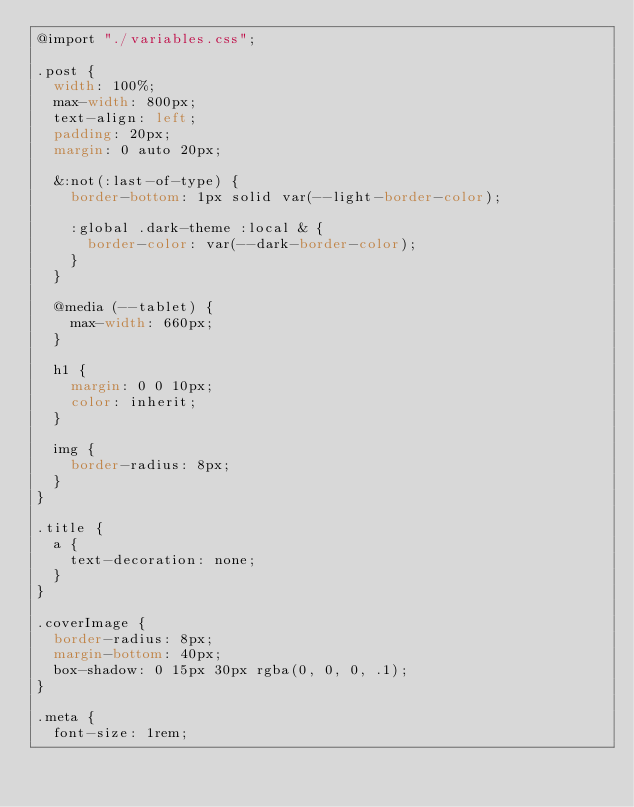Convert code to text. <code><loc_0><loc_0><loc_500><loc_500><_CSS_>@import "./variables.css";

.post {
  width: 100%;
  max-width: 800px;
  text-align: left;
  padding: 20px;
  margin: 0 auto 20px;

  &:not(:last-of-type) {
    border-bottom: 1px solid var(--light-border-color);

    :global .dark-theme :local & {
      border-color: var(--dark-border-color);
    }
  }

  @media (--tablet) {
    max-width: 660px;
  }

  h1 {
    margin: 0 0 10px;
    color: inherit;
  }

  img {
    border-radius: 8px;
  }
}

.title {
  a {
    text-decoration: none;
  }
}

.coverImage {
  border-radius: 8px;
  margin-bottom: 40px;
  box-shadow: 0 15px 30px rgba(0, 0, 0, .1);
}

.meta {
  font-size: 1rem;</code> 